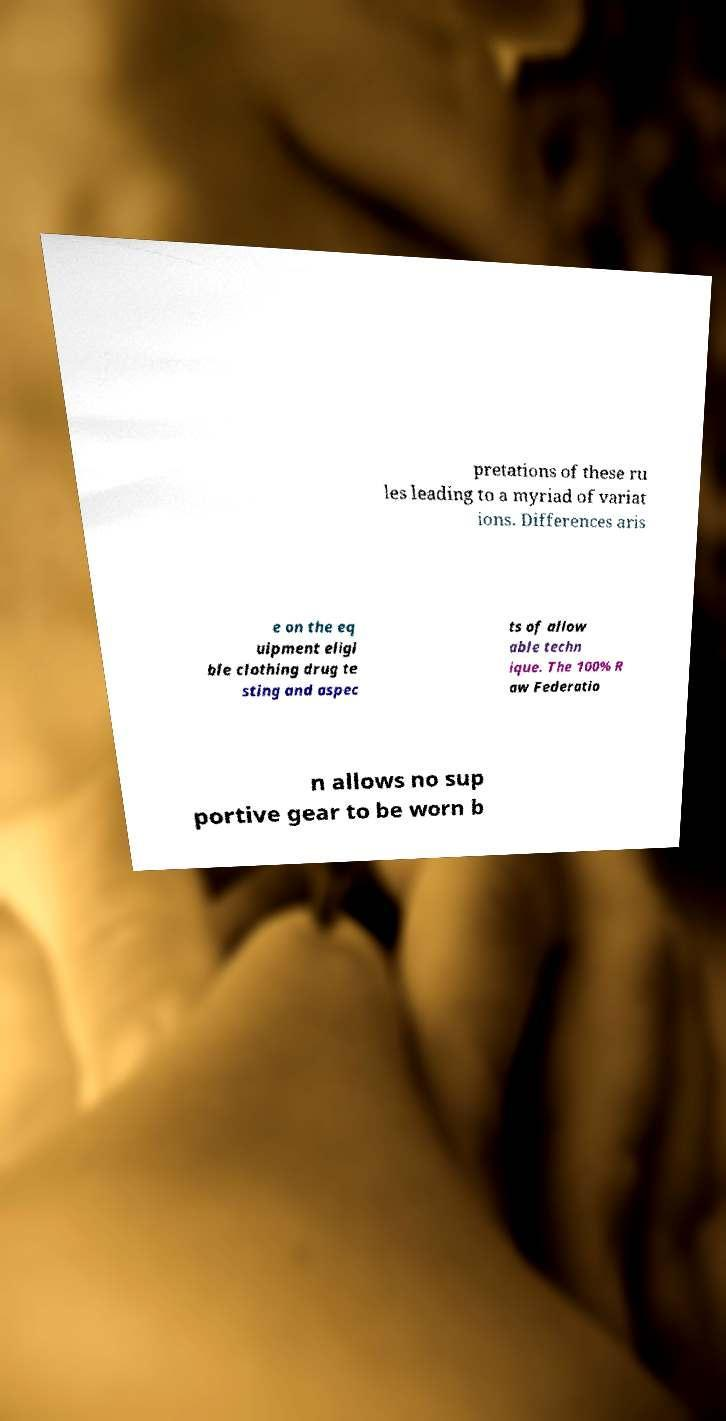Could you assist in decoding the text presented in this image and type it out clearly? pretations of these ru les leading to a myriad of variat ions. Differences aris e on the eq uipment eligi ble clothing drug te sting and aspec ts of allow able techn ique. The 100% R aw Federatio n allows no sup portive gear to be worn b 